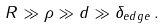<formula> <loc_0><loc_0><loc_500><loc_500>R \gg \rho \gg d \gg \delta _ { e d g e } \, .</formula> 